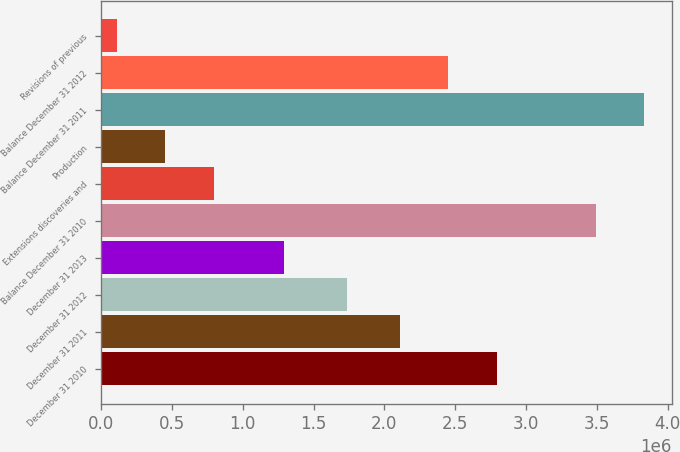<chart> <loc_0><loc_0><loc_500><loc_500><bar_chart><fcel>December 31 2010<fcel>December 31 2011<fcel>December 31 2012<fcel>December 31 2013<fcel>Balance December 31 2010<fcel>Extensions discoveries and<fcel>Production<fcel>Balance December 31 2011<fcel>Balance December 31 2012<fcel>Revisions of previous<nl><fcel>2.79639e+06<fcel>2.1088e+06<fcel>1.73466e+06<fcel>1.29442e+06<fcel>3.49197e+06<fcel>797143<fcel>453347<fcel>3.83576e+06<fcel>2.4526e+06<fcel>109551<nl></chart> 